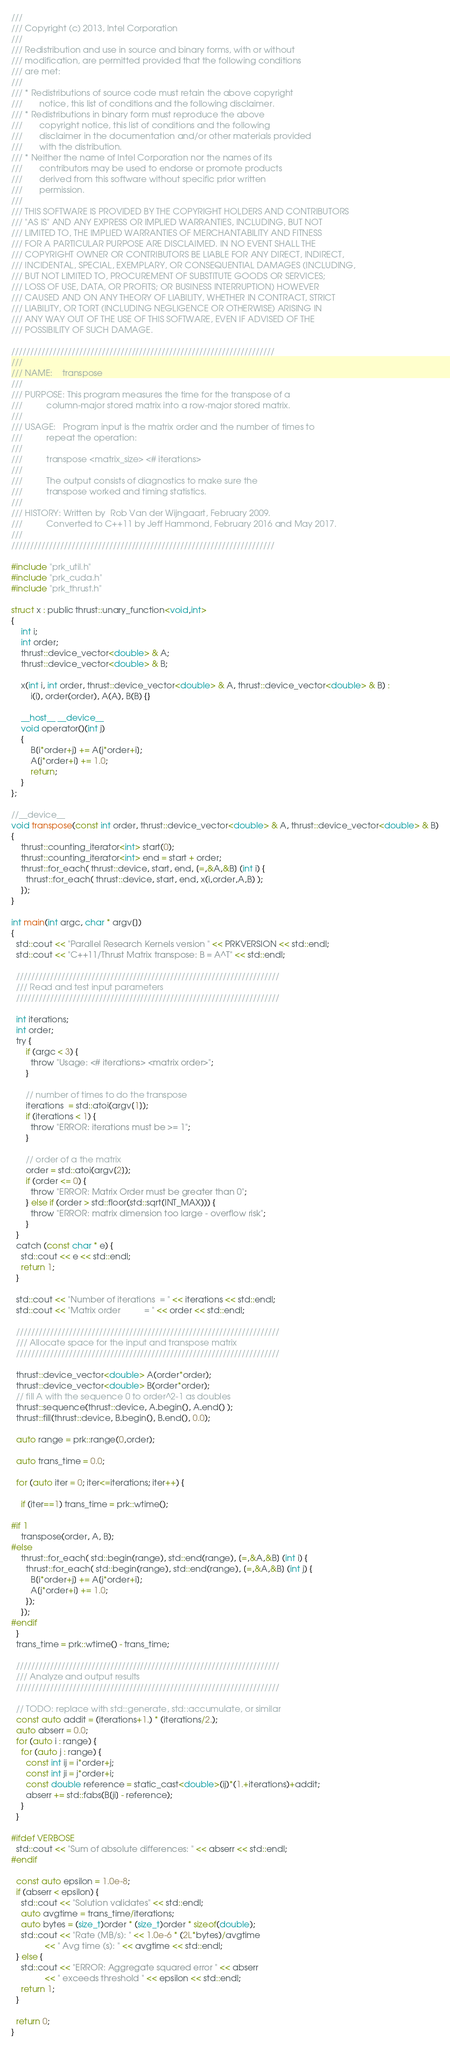Convert code to text. <code><loc_0><loc_0><loc_500><loc_500><_Cuda_>///
/// Copyright (c) 2013, Intel Corporation
///
/// Redistribution and use in source and binary forms, with or without
/// modification, are permitted provided that the following conditions
/// are met:
///
/// * Redistributions of source code must retain the above copyright
///       notice, this list of conditions and the following disclaimer.
/// * Redistributions in binary form must reproduce the above
///       copyright notice, this list of conditions and the following
///       disclaimer in the documentation and/or other materials provided
///       with the distribution.
/// * Neither the name of Intel Corporation nor the names of its
///       contributors may be used to endorse or promote products
///       derived from this software without specific prior written
///       permission.
///
/// THIS SOFTWARE IS PROVIDED BY THE COPYRIGHT HOLDERS AND CONTRIBUTORS
/// "AS IS" AND ANY EXPRESS OR IMPLIED WARRANTIES, INCLUDING, BUT NOT
/// LIMITED TO, THE IMPLIED WARRANTIES OF MERCHANTABILITY AND FITNESS
/// FOR A PARTICULAR PURPOSE ARE DISCLAIMED. IN NO EVENT SHALL THE
/// COPYRIGHT OWNER OR CONTRIBUTORS BE LIABLE FOR ANY DIRECT, INDIRECT,
/// INCIDENTAL, SPECIAL, EXEMPLARY, OR CONSEQUENTIAL DAMAGES (INCLUDING,
/// BUT NOT LIMITED TO, PROCUREMENT OF SUBSTITUTE GOODS OR SERVICES;
/// LOSS OF USE, DATA, OR PROFITS; OR BUSINESS INTERRUPTION) HOWEVER
/// CAUSED AND ON ANY THEORY OF LIABILITY, WHETHER IN CONTRACT, STRICT
/// LIABILITY, OR TORT (INCLUDING NEGLIGENCE OR OTHERWISE) ARISING IN
/// ANY WAY OUT OF THE USE OF THIS SOFTWARE, EVEN IF ADVISED OF THE
/// POSSIBILITY OF SUCH DAMAGE.

//////////////////////////////////////////////////////////////////////
///
/// NAME:    transpose
///
/// PURPOSE: This program measures the time for the transpose of a
///          column-major stored matrix into a row-major stored matrix.
///
/// USAGE:   Program input is the matrix order and the number of times to
///          repeat the operation:
///
///          transpose <matrix_size> <# iterations>
///
///          The output consists of diagnostics to make sure the
///          transpose worked and timing statistics.
///
/// HISTORY: Written by  Rob Van der Wijngaart, February 2009.
///          Converted to C++11 by Jeff Hammond, February 2016 and May 2017.
///
//////////////////////////////////////////////////////////////////////

#include "prk_util.h"
#include "prk_cuda.h"
#include "prk_thrust.h"

struct x : public thrust::unary_function<void,int>
{
    int i;
    int order;
    thrust::device_vector<double> & A;
    thrust::device_vector<double> & B;

    x(int i, int order, thrust::device_vector<double> & A, thrust::device_vector<double> & B) :
        i(i), order(order), A(A), B(B) {}

    __host__ __device__
    void operator()(int j)
    {
        B[i*order+j] += A[j*order+i];
        A[j*order+i] += 1.0;
        return;
    }
};

//__device__
void transpose(const int order, thrust::device_vector<double> & A, thrust::device_vector<double> & B)
{
    thrust::counting_iterator<int> start(0);
    thrust::counting_iterator<int> end = start + order;
    thrust::for_each( thrust::device, start, end, [=,&A,&B] (int i) {
      thrust::for_each( thrust::device, start, end, x(i,order,A,B) );
    });
}

int main(int argc, char * argv[])
{
  std::cout << "Parallel Research Kernels version " << PRKVERSION << std::endl;
  std::cout << "C++11/Thrust Matrix transpose: B = A^T" << std::endl;

  //////////////////////////////////////////////////////////////////////
  /// Read and test input parameters
  //////////////////////////////////////////////////////////////////////

  int iterations;
  int order;
  try {
      if (argc < 3) {
        throw "Usage: <# iterations> <matrix order>";
      }

      // number of times to do the transpose
      iterations  = std::atoi(argv[1]);
      if (iterations < 1) {
        throw "ERROR: iterations must be >= 1";
      }

      // order of a the matrix
      order = std::atoi(argv[2]);
      if (order <= 0) {
        throw "ERROR: Matrix Order must be greater than 0";
      } else if (order > std::floor(std::sqrt(INT_MAX))) {
        throw "ERROR: matrix dimension too large - overflow risk";
      }
  }
  catch (const char * e) {
    std::cout << e << std::endl;
    return 1;
  }

  std::cout << "Number of iterations  = " << iterations << std::endl;
  std::cout << "Matrix order          = " << order << std::endl;

  //////////////////////////////////////////////////////////////////////
  /// Allocate space for the input and transpose matrix
  //////////////////////////////////////////////////////////////////////

  thrust::device_vector<double> A(order*order);
  thrust::device_vector<double> B(order*order);
  // fill A with the sequence 0 to order^2-1 as doubles
  thrust::sequence(thrust::device, A.begin(), A.end() );
  thrust::fill(thrust::device, B.begin(), B.end(), 0.0);

  auto range = prk::range(0,order);

  auto trans_time = 0.0;

  for (auto iter = 0; iter<=iterations; iter++) {

    if (iter==1) trans_time = prk::wtime();

#if 1
    transpose(order, A, B);
#else
    thrust::for_each( std::begin(range), std::end(range), [=,&A,&B] (int i) {
      thrust::for_each( std::begin(range), std::end(range), [=,&A,&B] (int j) {
        B[i*order+j] += A[j*order+i];
        A[j*order+i] += 1.0;
      });
    });
#endif
  }
  trans_time = prk::wtime() - trans_time;

  //////////////////////////////////////////////////////////////////////
  /// Analyze and output results
  //////////////////////////////////////////////////////////////////////

  // TODO: replace with std::generate, std::accumulate, or similar
  const auto addit = (iterations+1.) * (iterations/2.);
  auto abserr = 0.0;
  for (auto i : range) {
    for (auto j : range) {
      const int ij = i*order+j;
      const int ji = j*order+i;
      const double reference = static_cast<double>(ij)*(1.+iterations)+addit;
      abserr += std::fabs(B[ji] - reference);
    }
  }

#ifdef VERBOSE
  std::cout << "Sum of absolute differences: " << abserr << std::endl;
#endif

  const auto epsilon = 1.0e-8;
  if (abserr < epsilon) {
    std::cout << "Solution validates" << std::endl;
    auto avgtime = trans_time/iterations;
    auto bytes = (size_t)order * (size_t)order * sizeof(double);
    std::cout << "Rate (MB/s): " << 1.0e-6 * (2L*bytes)/avgtime
              << " Avg time (s): " << avgtime << std::endl;
  } else {
    std::cout << "ERROR: Aggregate squared error " << abserr
              << " exceeds threshold " << epsilon << std::endl;
    return 1;
  }

  return 0;
}


</code> 